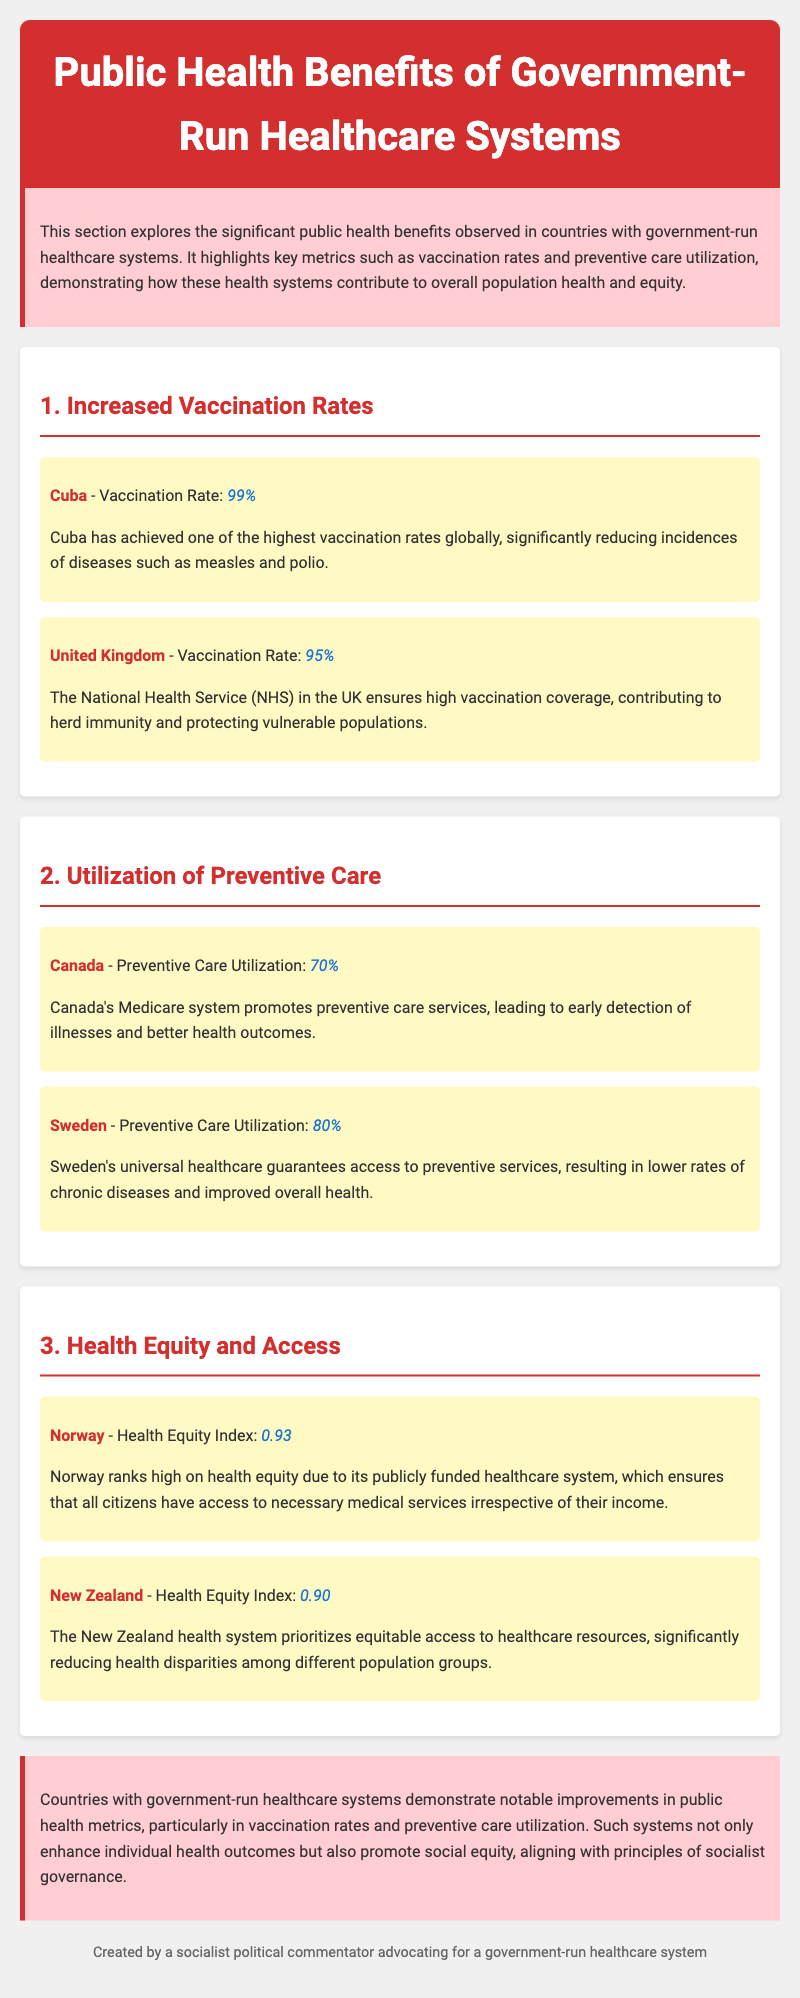What is Cuba's vaccination rate? The document states that Cuba has achieved a vaccination rate of 99%.
Answer: 99% What is the preventive care utilization rate in Canada? The document indicates that Canada's preventive care utilization rate is 70%.
Answer: 70% Which country ranks highest in health equity according to the document? The document mentions that Norway ranks high on health equity with an index of 0.93.
Answer: Norway What is the vaccination rate in the United Kingdom? The document specifies that the vaccination rate in the United Kingdom is 95%.
Answer: 95% How does Sweden's preventive care utilization compare to Canada's? The document shows that Sweden's preventive care utilization is 80%, which is higher than Canada's 70%.
Answer: Higher What is the health equity index for New Zealand? The document states that New Zealand has a health equity index of 0.90.
Answer: 0.90 What common outcome do government-run healthcare systems achieve regarding public health? The conclusion states that these systems demonstrate notable improvements in public health metrics.
Answer: Notable improvements What is one of the key benefits of government-run healthcare systems highlighted in the introduction? The introduction highlights that these systems contribute to overall population health and equity.
Answer: Population health and equity What demographic benefit does Norway's healthcare system provide? The document notes that Norway's system ensures access to necessary medical services irrespective of income.
Answer: Access to necessary medical services 